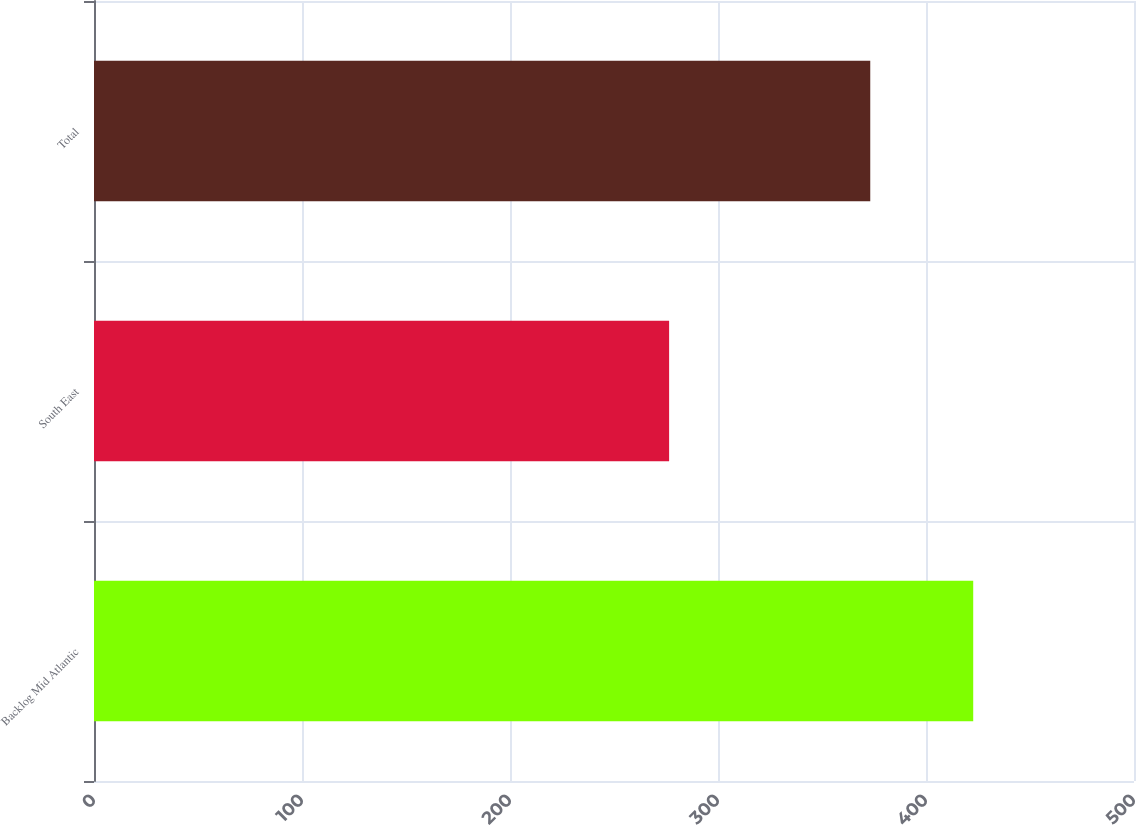Convert chart to OTSL. <chart><loc_0><loc_0><loc_500><loc_500><bar_chart><fcel>Backlog Mid Atlantic<fcel>South East<fcel>Total<nl><fcel>422.7<fcel>276.5<fcel>373.2<nl></chart> 